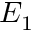<formula> <loc_0><loc_0><loc_500><loc_500>E _ { 1 }</formula> 